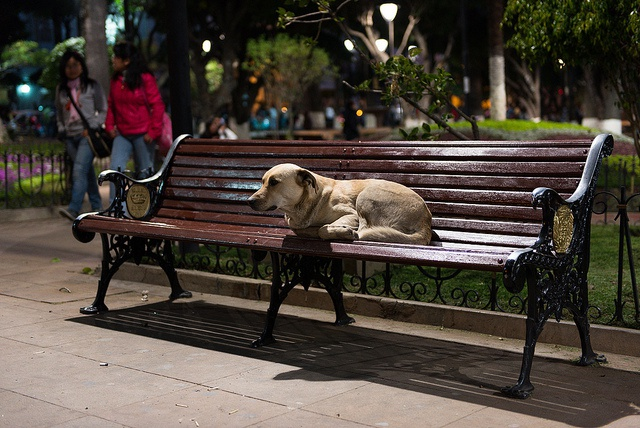Describe the objects in this image and their specific colors. I can see bench in black, maroon, gray, and lightgray tones, dog in black, gray, and maroon tones, people in black, maroon, brown, and gray tones, people in black, gray, and maroon tones, and handbag in black, maroon, and gray tones in this image. 